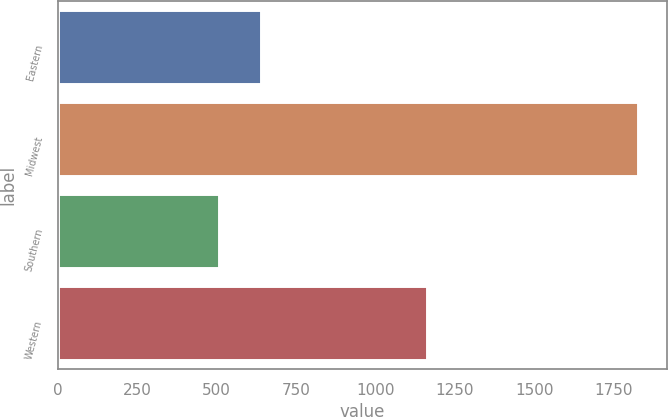Convert chart. <chart><loc_0><loc_0><loc_500><loc_500><bar_chart><fcel>Eastern<fcel>Midwest<fcel>Southern<fcel>Western<nl><fcel>639<fcel>1827<fcel>507<fcel>1162<nl></chart> 